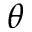<formula> <loc_0><loc_0><loc_500><loc_500>\theta</formula> 